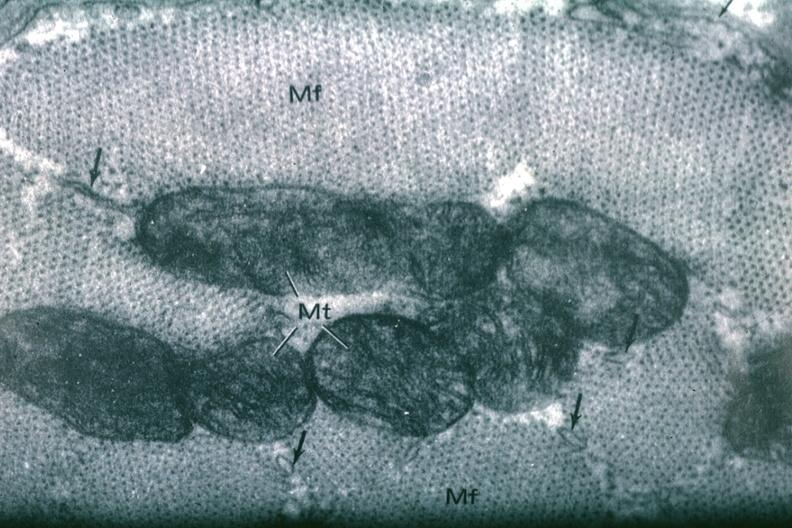s metastatic carcinoma prostate present?
Answer the question using a single word or phrase. No 